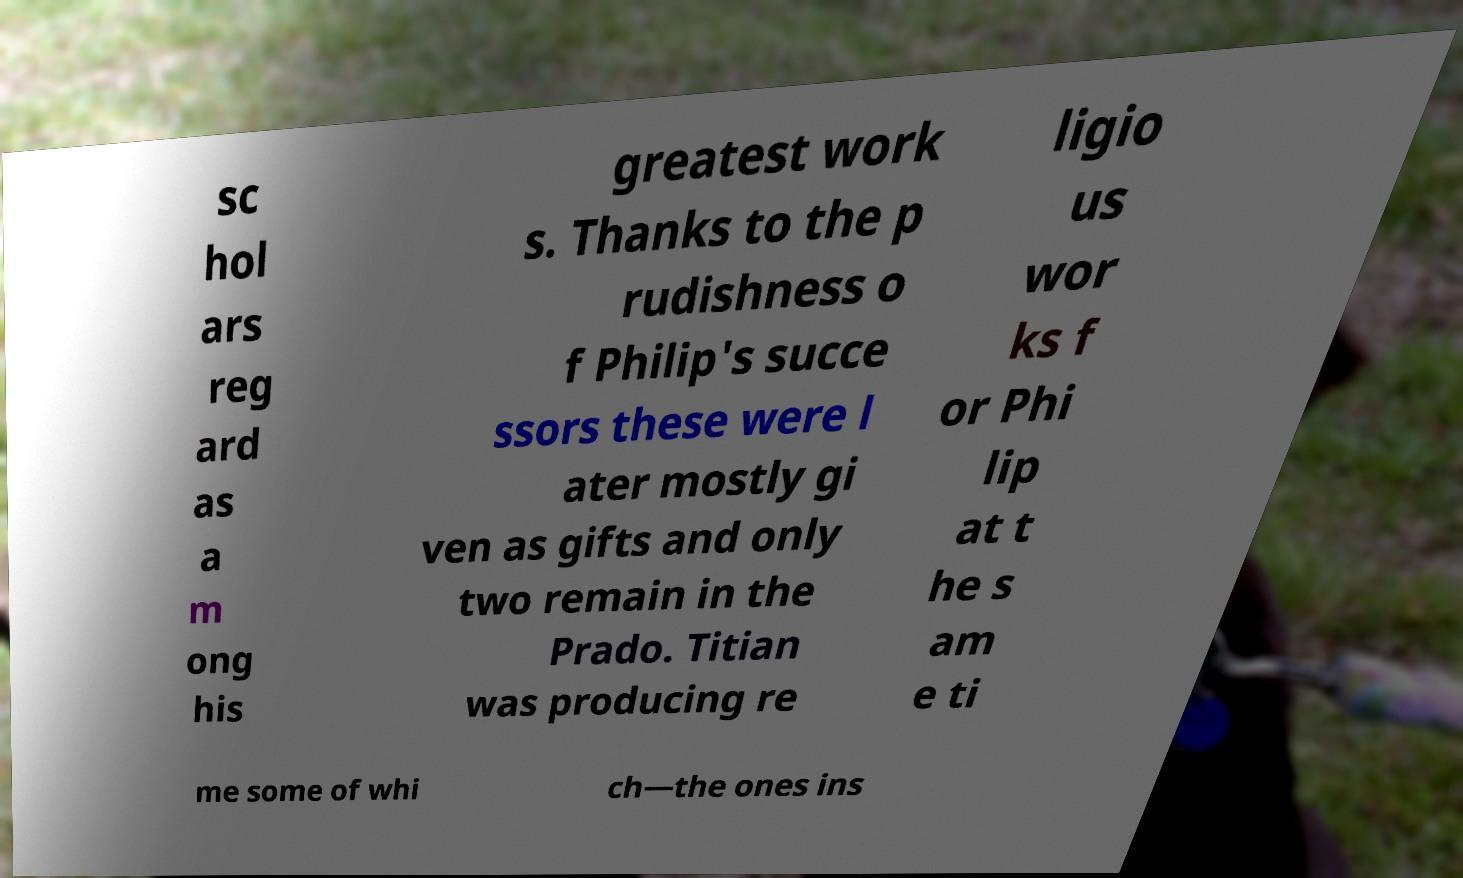Please read and relay the text visible in this image. What does it say? sc hol ars reg ard as a m ong his greatest work s. Thanks to the p rudishness o f Philip's succe ssors these were l ater mostly gi ven as gifts and only two remain in the Prado. Titian was producing re ligio us wor ks f or Phi lip at t he s am e ti me some of whi ch—the ones ins 